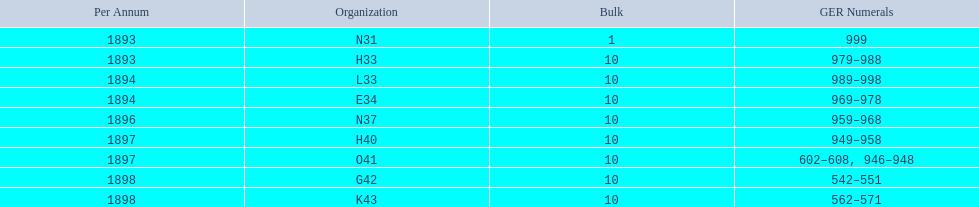What is the last year listed? 1898. 